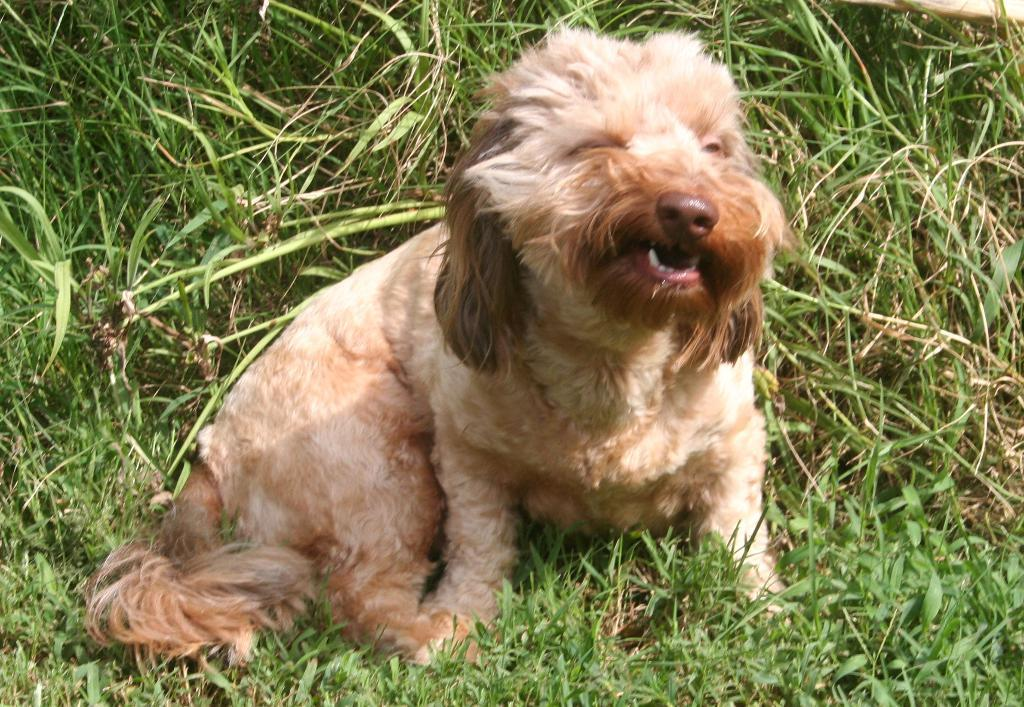What type of animal can be seen in the picture? There is a dog in the picture. What is visible at the bottom of the picture? Grass is visible at the bottom of the picture. What can be seen in the background of the picture? Grass is present in the background of the picture. What type of dinner is being served in the picture? There is no dinner present in the picture; it features a dog and grass. Can you describe how the dog is jumping in the picture? There is no indication of the dog jumping in the picture; it is simply standing or sitting. 